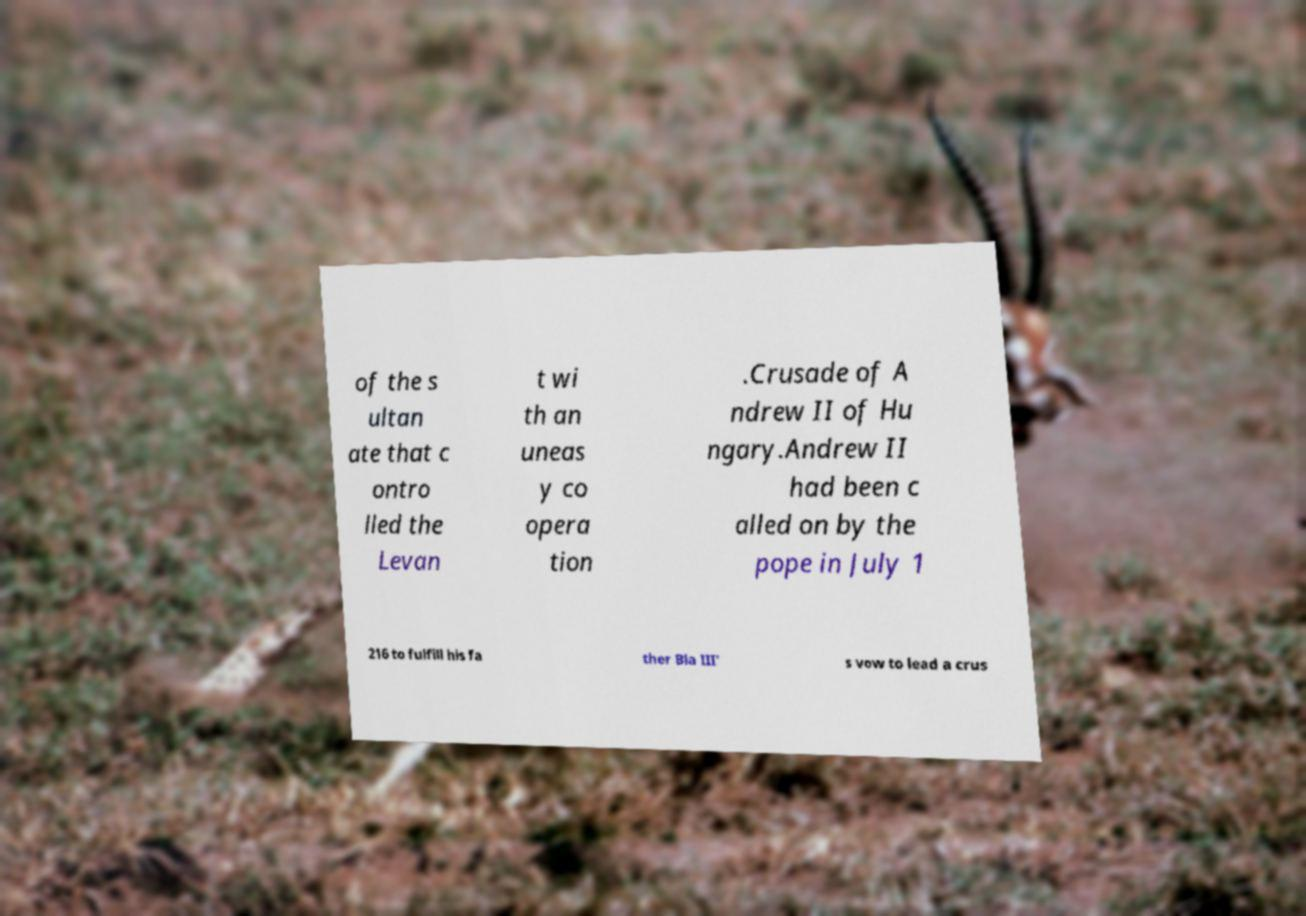Please read and relay the text visible in this image. What does it say? of the s ultan ate that c ontro lled the Levan t wi th an uneas y co opera tion .Crusade of A ndrew II of Hu ngary.Andrew II had been c alled on by the pope in July 1 216 to fulfill his fa ther Bla III' s vow to lead a crus 